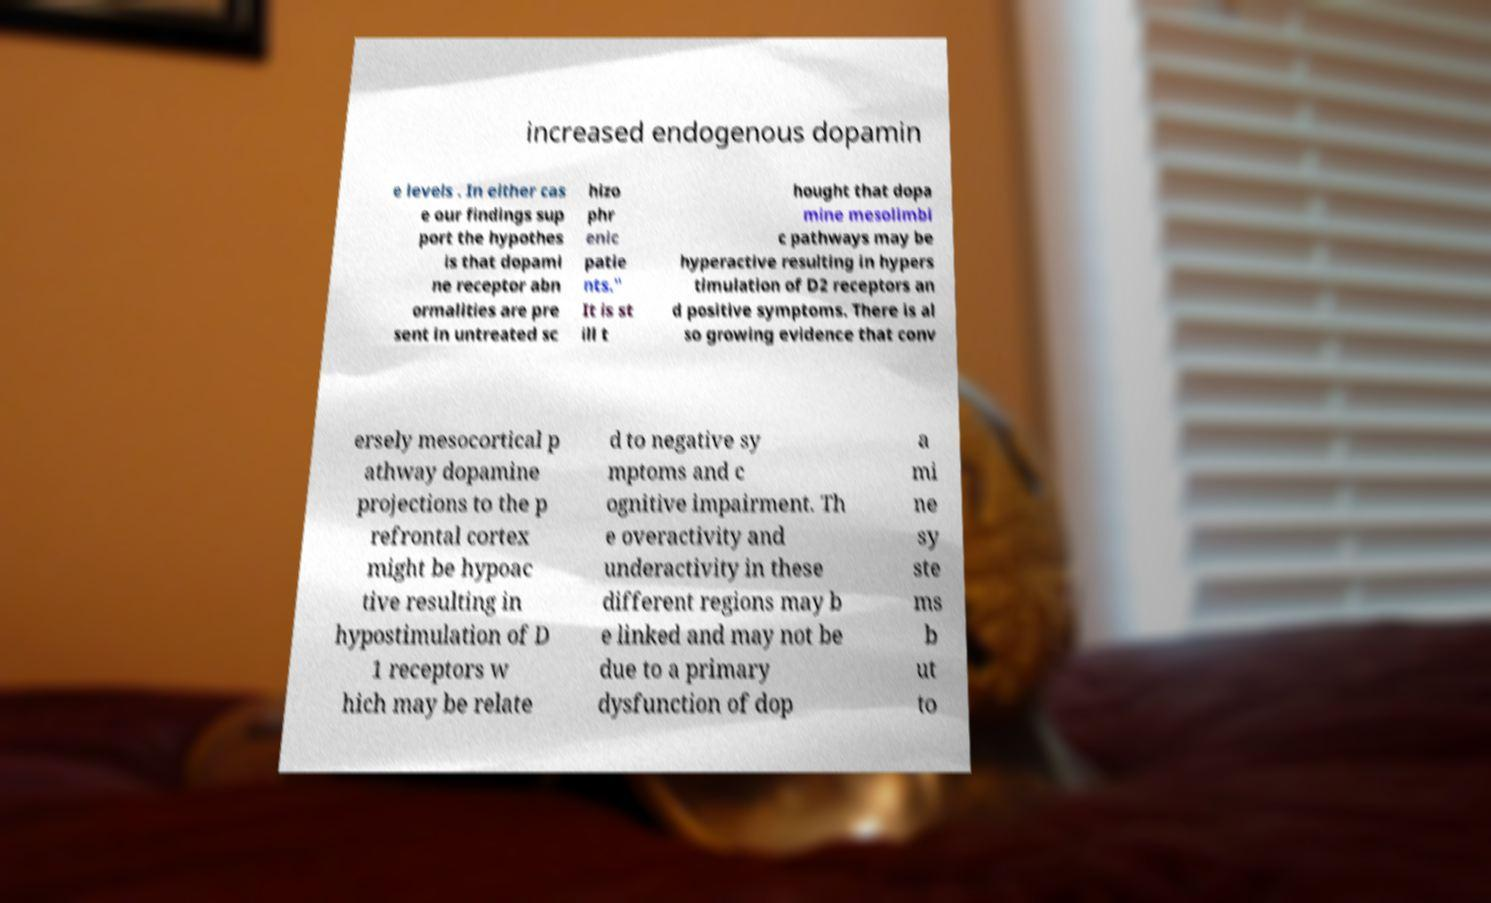For documentation purposes, I need the text within this image transcribed. Could you provide that? increased endogenous dopamin e levels . In either cas e our findings sup port the hypothes is that dopami ne receptor abn ormalities are pre sent in untreated sc hizo phr enic patie nts." It is st ill t hought that dopa mine mesolimbi c pathways may be hyperactive resulting in hypers timulation of D2 receptors an d positive symptoms. There is al so growing evidence that conv ersely mesocortical p athway dopamine projections to the p refrontal cortex might be hypoac tive resulting in hypostimulation of D 1 receptors w hich may be relate d to negative sy mptoms and c ognitive impairment. Th e overactivity and underactivity in these different regions may b e linked and may not be due to a primary dysfunction of dop a mi ne sy ste ms b ut to 